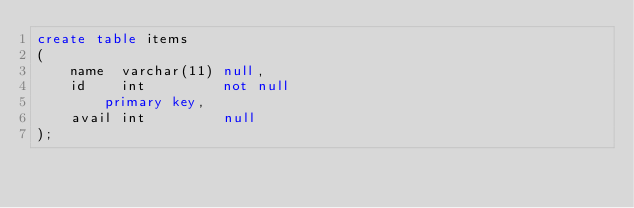Convert code to text. <code><loc_0><loc_0><loc_500><loc_500><_SQL_>create table items
(
    name  varchar(11) null,
    id    int         not null
        primary key,
    avail int         null
);
</code> 